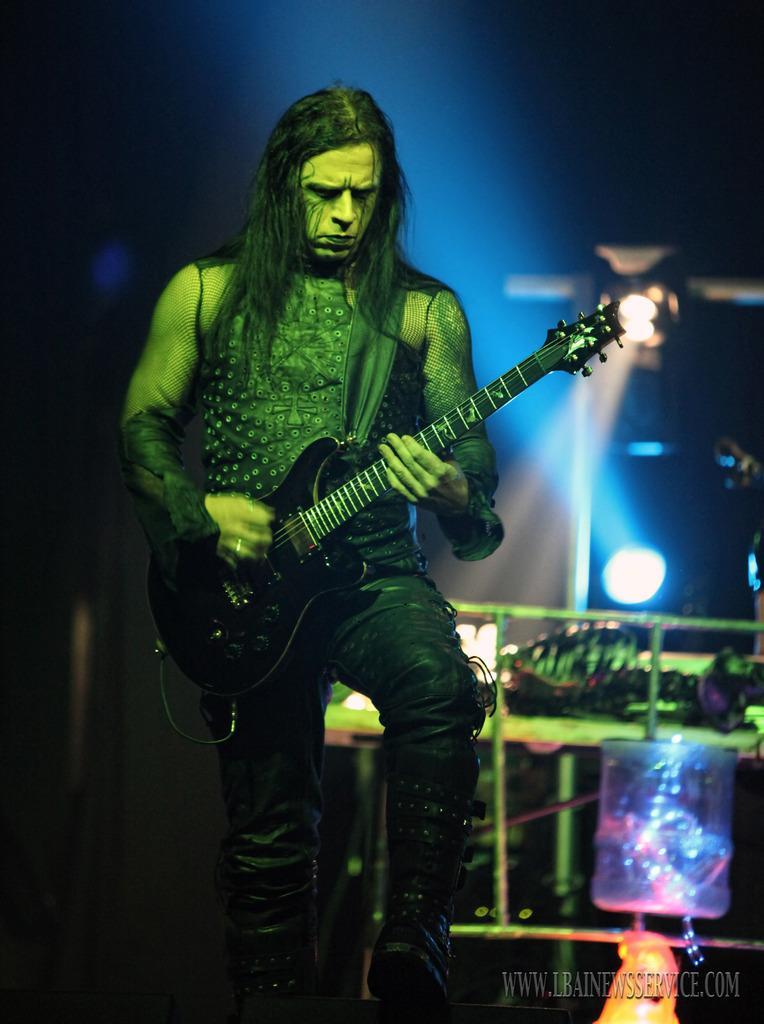Describe this image in one or two sentences. In the given image we can see that man is standing and catching a guitar in his hand. This is a watermark. This is a light. 